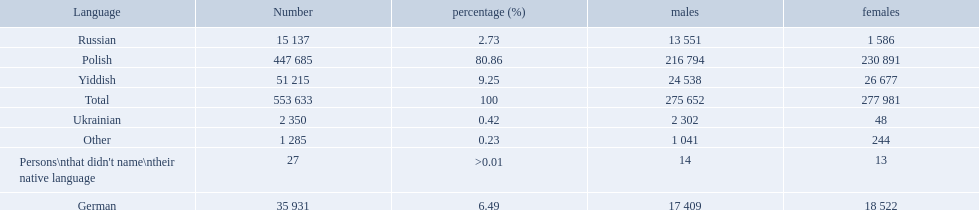Which language options are listed? Polish, Yiddish, German, Russian, Ukrainian, Other, Persons\nthat didn't name\ntheir native language. Of these, which did .42% of the people select? Ukrainian. What language makes a majority Polish. What the the total number of speakers? 553 633. 